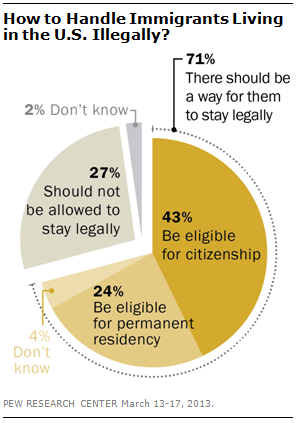Give some essential details in this illustration. The color of the largest pie is dark yellow. The value of "don't know" is approximately 0.02%. 